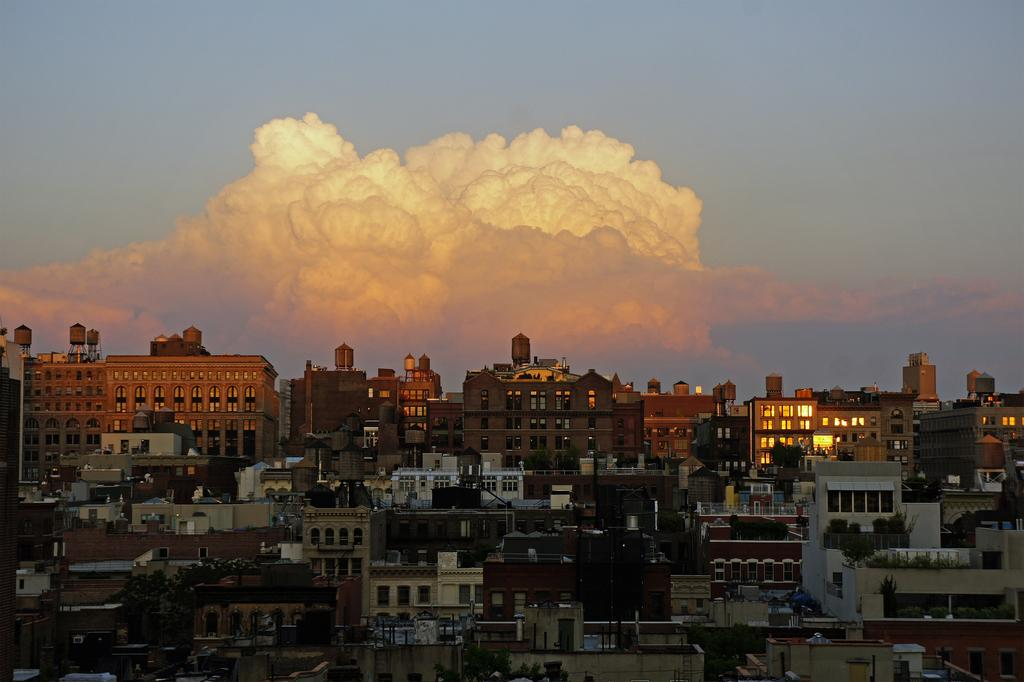What type of structures can be seen in the image? There are buildings in the image. What type of vegetation is present in the image? There are trees in the image. What can be seen in the background of the image? There is a cloud visible in the background of the image. What type of selection process is being conducted in the image? There is no indication of a selection process in the image; it features buildings, trees, and a cloud. What nation is represented in the image? The image does not represent any specific nation; it simply shows buildings, trees, and a cloud. 